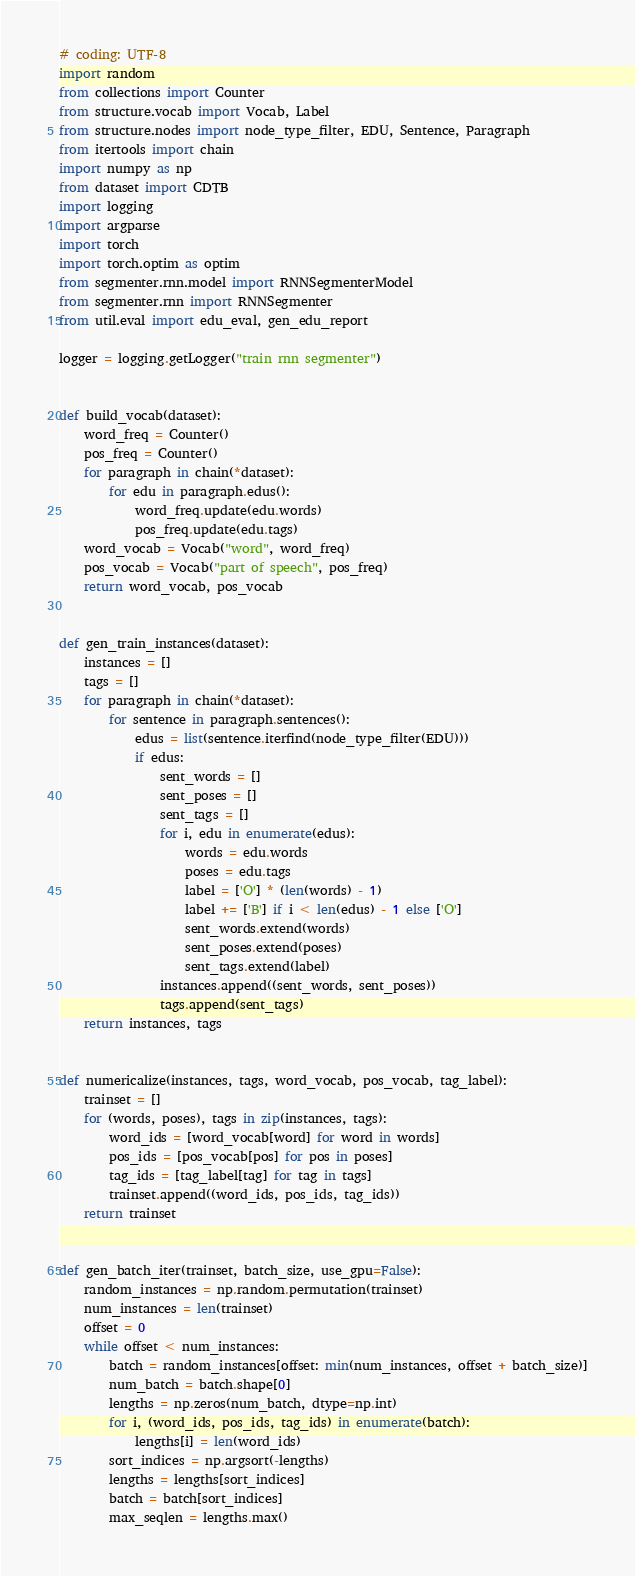<code> <loc_0><loc_0><loc_500><loc_500><_Python_># coding: UTF-8
import random
from collections import Counter
from structure.vocab import Vocab, Label
from structure.nodes import node_type_filter, EDU, Sentence, Paragraph
from itertools import chain
import numpy as np
from dataset import CDTB
import logging
import argparse
import torch
import torch.optim as optim
from segmenter.rnn.model import RNNSegmenterModel
from segmenter.rnn import RNNSegmenter
from util.eval import edu_eval, gen_edu_report

logger = logging.getLogger("train rnn segmenter")


def build_vocab(dataset):
    word_freq = Counter()
    pos_freq = Counter()
    for paragraph in chain(*dataset):
        for edu in paragraph.edus():
            word_freq.update(edu.words)
            pos_freq.update(edu.tags)
    word_vocab = Vocab("word", word_freq)
    pos_vocab = Vocab("part of speech", pos_freq)
    return word_vocab, pos_vocab


def gen_train_instances(dataset):
    instances = []
    tags = []
    for paragraph in chain(*dataset):
        for sentence in paragraph.sentences():
            edus = list(sentence.iterfind(node_type_filter(EDU)))
            if edus:
                sent_words = []
                sent_poses = []
                sent_tags = []
                for i, edu in enumerate(edus):
                    words = edu.words
                    poses = edu.tags
                    label = ['O'] * (len(words) - 1)
                    label += ['B'] if i < len(edus) - 1 else ['O']
                    sent_words.extend(words)
                    sent_poses.extend(poses)
                    sent_tags.extend(label)
                instances.append((sent_words, sent_poses))
                tags.append(sent_tags)
    return instances, tags


def numericalize(instances, tags, word_vocab, pos_vocab, tag_label):
    trainset = []
    for (words, poses), tags in zip(instances, tags):
        word_ids = [word_vocab[word] for word in words]
        pos_ids = [pos_vocab[pos] for pos in poses]
        tag_ids = [tag_label[tag] for tag in tags]
        trainset.append((word_ids, pos_ids, tag_ids))
    return trainset


def gen_batch_iter(trainset, batch_size, use_gpu=False):
    random_instances = np.random.permutation(trainset)
    num_instances = len(trainset)
    offset = 0
    while offset < num_instances:
        batch = random_instances[offset: min(num_instances, offset + batch_size)]
        num_batch = batch.shape[0]
        lengths = np.zeros(num_batch, dtype=np.int)
        for i, (word_ids, pos_ids, tag_ids) in enumerate(batch):
            lengths[i] = len(word_ids)
        sort_indices = np.argsort(-lengths)
        lengths = lengths[sort_indices]
        batch = batch[sort_indices]
        max_seqlen = lengths.max()</code> 